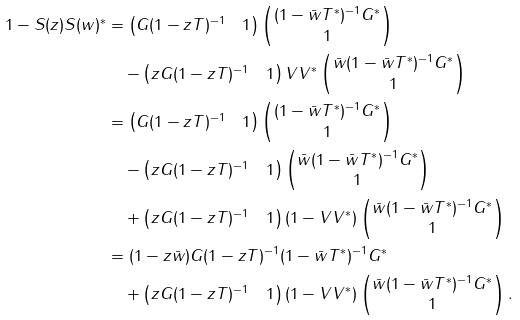Convert formula to latex. <formula><loc_0><loc_0><loc_500><loc_500>1 - S ( z ) S ( w ) ^ { * } & = \begin{pmatrix} G ( 1 - z T ) ^ { - 1 } & 1 \end{pmatrix} \begin{pmatrix} ( 1 - \bar { w } T ^ { * } ) ^ { - 1 } G ^ { * } \\ 1 \end{pmatrix} \\ & \quad - \begin{pmatrix} z G ( 1 - z T ) ^ { - 1 } & 1 \end{pmatrix} V V ^ { * } \begin{pmatrix} \bar { w } ( 1 - \bar { w } T ^ { * } ) ^ { - 1 } G ^ { * } \\ 1 \end{pmatrix} \\ & = \begin{pmatrix} G ( 1 - z T ) ^ { - 1 } & 1 \end{pmatrix} \begin{pmatrix} ( 1 - \bar { w } T ^ { * } ) ^ { - 1 } G ^ { * } \\ 1 \end{pmatrix} \\ & \quad - \begin{pmatrix} z G ( 1 - z T ) ^ { - 1 } & 1 \end{pmatrix} \begin{pmatrix} \bar { w } ( 1 - \bar { w } T ^ { * } ) ^ { - 1 } G ^ { * } \\ 1 \end{pmatrix} \\ & \quad + \begin{pmatrix} z G ( 1 - z T ) ^ { - 1 } & 1 \end{pmatrix} ( 1 - V V ^ { * } ) \begin{pmatrix} \bar { w } ( 1 - \bar { w } T ^ { * } ) ^ { - 1 } G ^ { * } \\ 1 \end{pmatrix} \\ & = ( 1 - z \bar { w } ) G ( 1 - z T ) ^ { - 1 } ( 1 - \bar { w } T ^ { * } ) ^ { - 1 } G ^ { * } \\ & \quad + \begin{pmatrix} z G ( 1 - z T ) ^ { - 1 } & 1 \end{pmatrix} ( 1 - V V ^ { * } ) \begin{pmatrix} \bar { w } ( 1 - \bar { w } T ^ { * } ) ^ { - 1 } G ^ { * } \\ 1 \end{pmatrix} .</formula> 